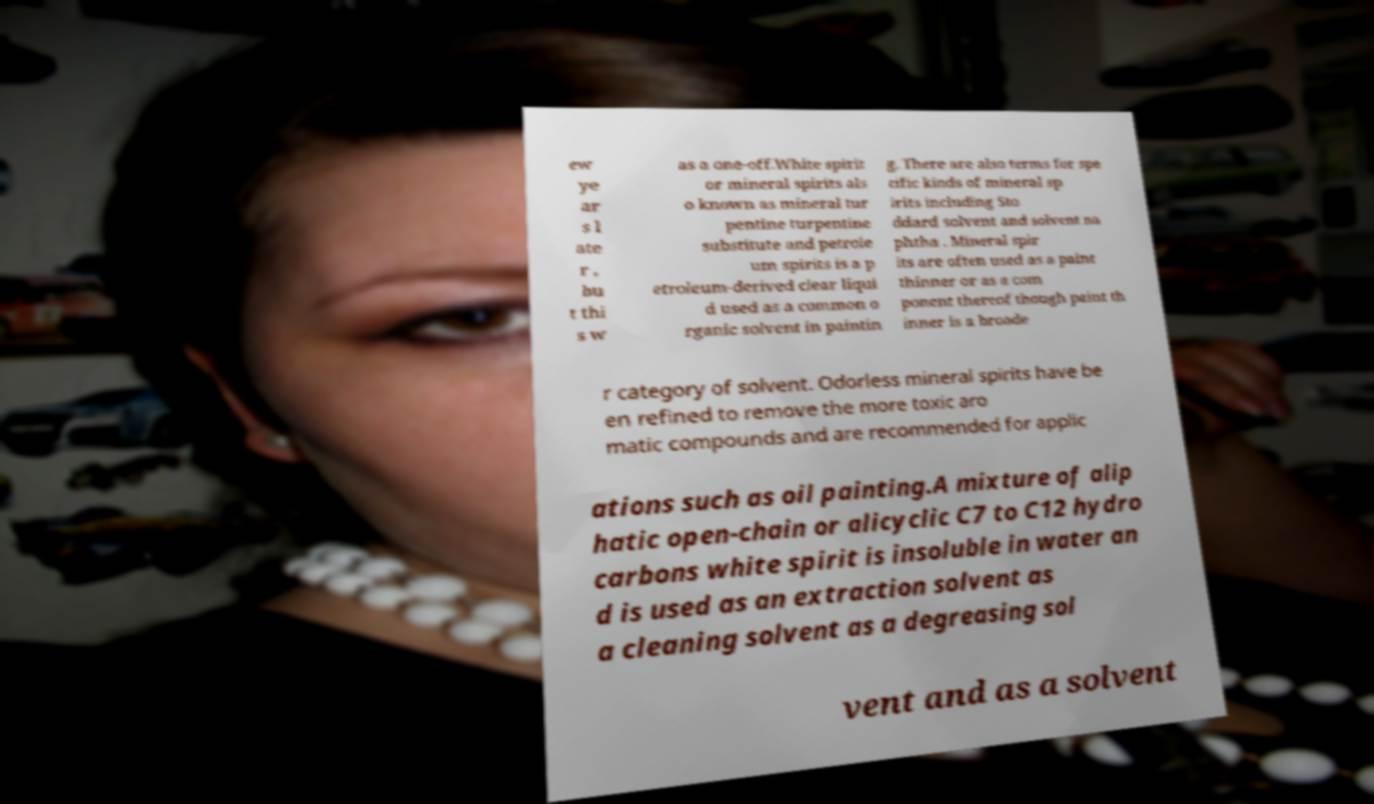Could you extract and type out the text from this image? ew ye ar s l ate r , bu t thi s w as a one-off.White spirit or mineral spirits als o known as mineral tur pentine turpentine substitute and petrole um spirits is a p etroleum-derived clear liqui d used as a common o rganic solvent in paintin g. There are also terms for spe cific kinds of mineral sp irits including Sto ddard solvent and solvent na phtha . Mineral spir its are often used as a paint thinner or as a com ponent thereof though paint th inner is a broade r category of solvent. Odorless mineral spirits have be en refined to remove the more toxic aro matic compounds and are recommended for applic ations such as oil painting.A mixture of alip hatic open-chain or alicyclic C7 to C12 hydro carbons white spirit is insoluble in water an d is used as an extraction solvent as a cleaning solvent as a degreasing sol vent and as a solvent 